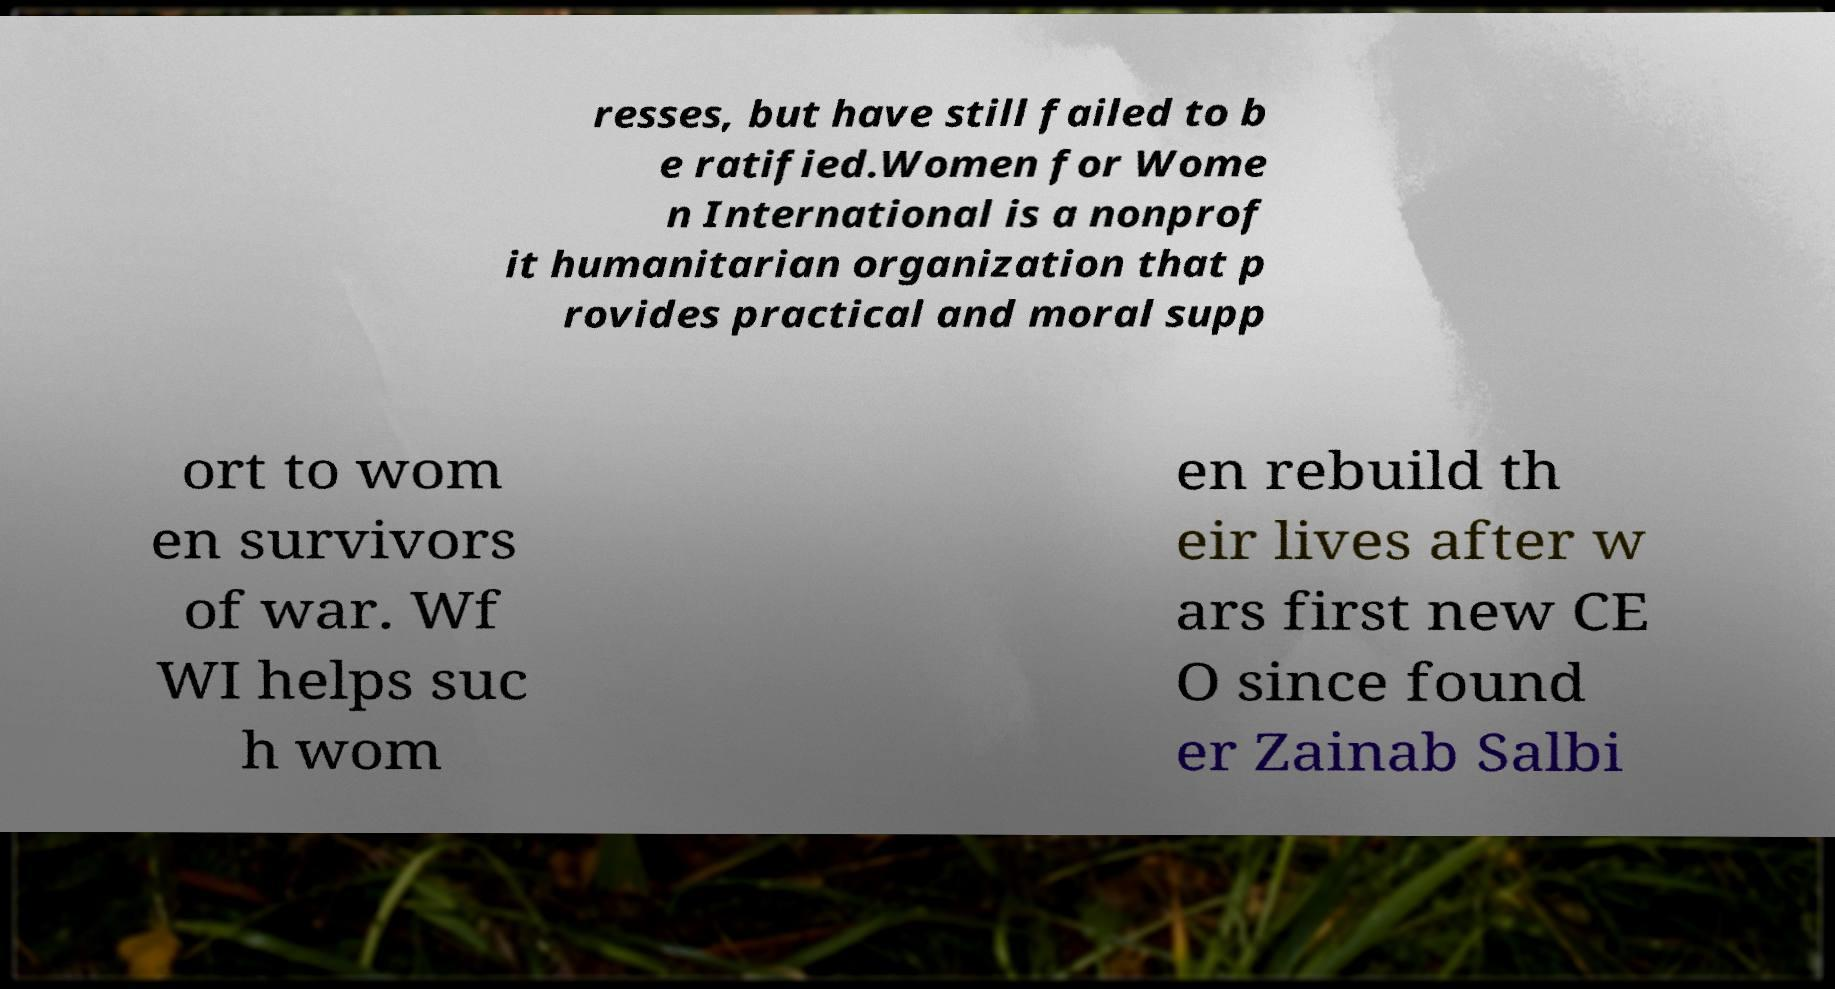For documentation purposes, I need the text within this image transcribed. Could you provide that? resses, but have still failed to b e ratified.Women for Wome n International is a nonprof it humanitarian organization that p rovides practical and moral supp ort to wom en survivors of war. Wf WI helps suc h wom en rebuild th eir lives after w ars first new CE O since found er Zainab Salbi 